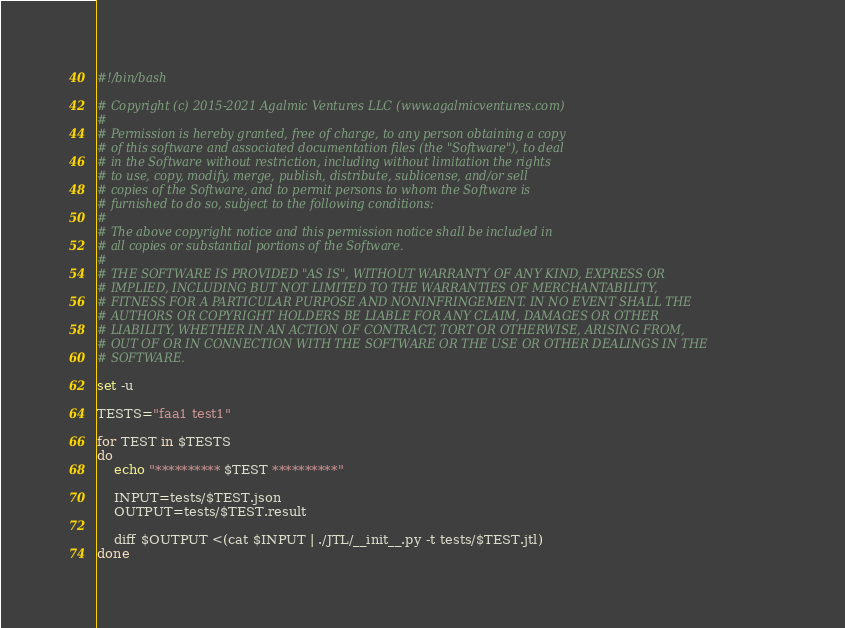Convert code to text. <code><loc_0><loc_0><loc_500><loc_500><_Bash_>#!/bin/bash

# Copyright (c) 2015-2021 Agalmic Ventures LLC (www.agalmicventures.com)
#
# Permission is hereby granted, free of charge, to any person obtaining a copy
# of this software and associated documentation files (the "Software"), to deal
# in the Software without restriction, including without limitation the rights
# to use, copy, modify, merge, publish, distribute, sublicense, and/or sell
# copies of the Software, and to permit persons to whom the Software is
# furnished to do so, subject to the following conditions:
#
# The above copyright notice and this permission notice shall be included in
# all copies or substantial portions of the Software.
#
# THE SOFTWARE IS PROVIDED "AS IS", WITHOUT WARRANTY OF ANY KIND, EXPRESS OR
# IMPLIED, INCLUDING BUT NOT LIMITED TO THE WARRANTIES OF MERCHANTABILITY,
# FITNESS FOR A PARTICULAR PURPOSE AND NONINFRINGEMENT. IN NO EVENT SHALL THE
# AUTHORS OR COPYRIGHT HOLDERS BE LIABLE FOR ANY CLAIM, DAMAGES OR OTHER
# LIABILITY, WHETHER IN AN ACTION OF CONTRACT, TORT OR OTHERWISE, ARISING FROM,
# OUT OF OR IN CONNECTION WITH THE SOFTWARE OR THE USE OR OTHER DEALINGS IN THE
# SOFTWARE.

set -u

TESTS="faa1 test1"

for TEST in $TESTS
do
	echo "********** $TEST **********"

	INPUT=tests/$TEST.json
	OUTPUT=tests/$TEST.result

	diff $OUTPUT <(cat $INPUT | ./JTL/__init__.py -t tests/$TEST.jtl)
done
</code> 